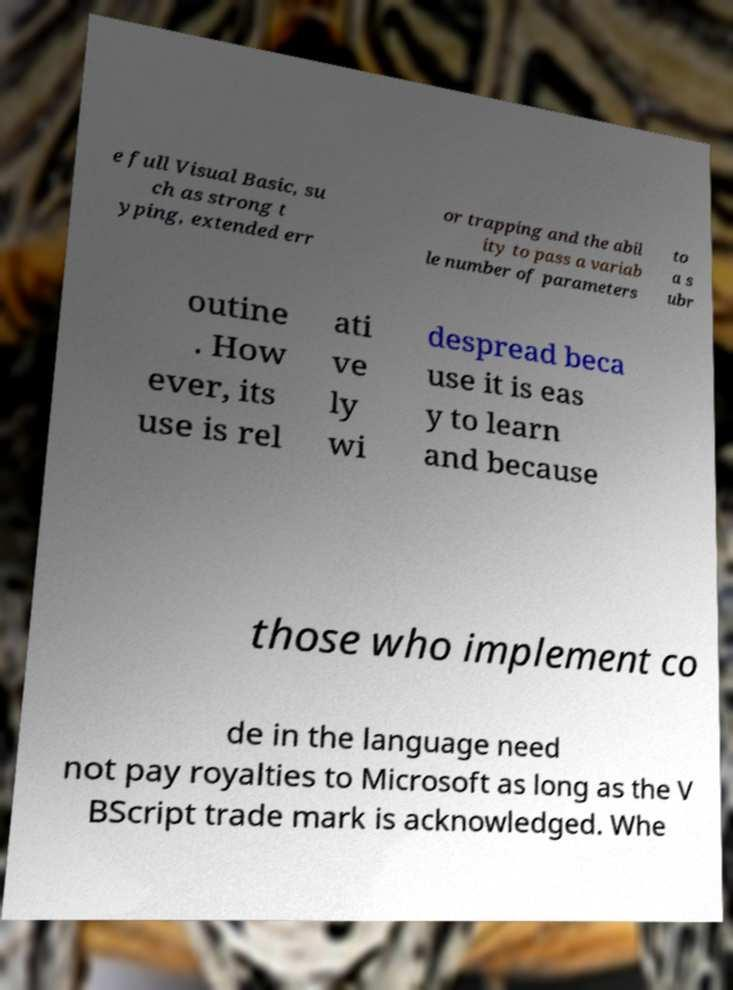There's text embedded in this image that I need extracted. Can you transcribe it verbatim? e full Visual Basic, su ch as strong t yping, extended err or trapping and the abil ity to pass a variab le number of parameters to a s ubr outine . How ever, its use is rel ati ve ly wi despread beca use it is eas y to learn and because those who implement co de in the language need not pay royalties to Microsoft as long as the V BScript trade mark is acknowledged. Whe 